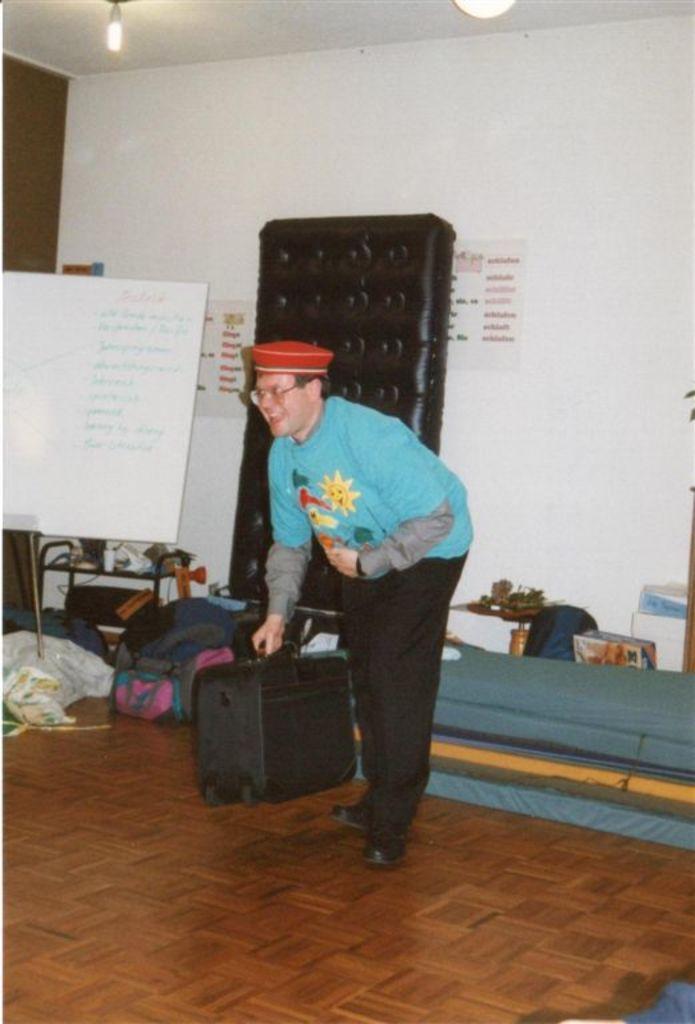How would you summarize this image in a sentence or two? a person i s wearing a blue t shirt and black pant, holding briefcase in his hand. to his left there is a whiteboard. behind that there is white wall on which there are notes. 